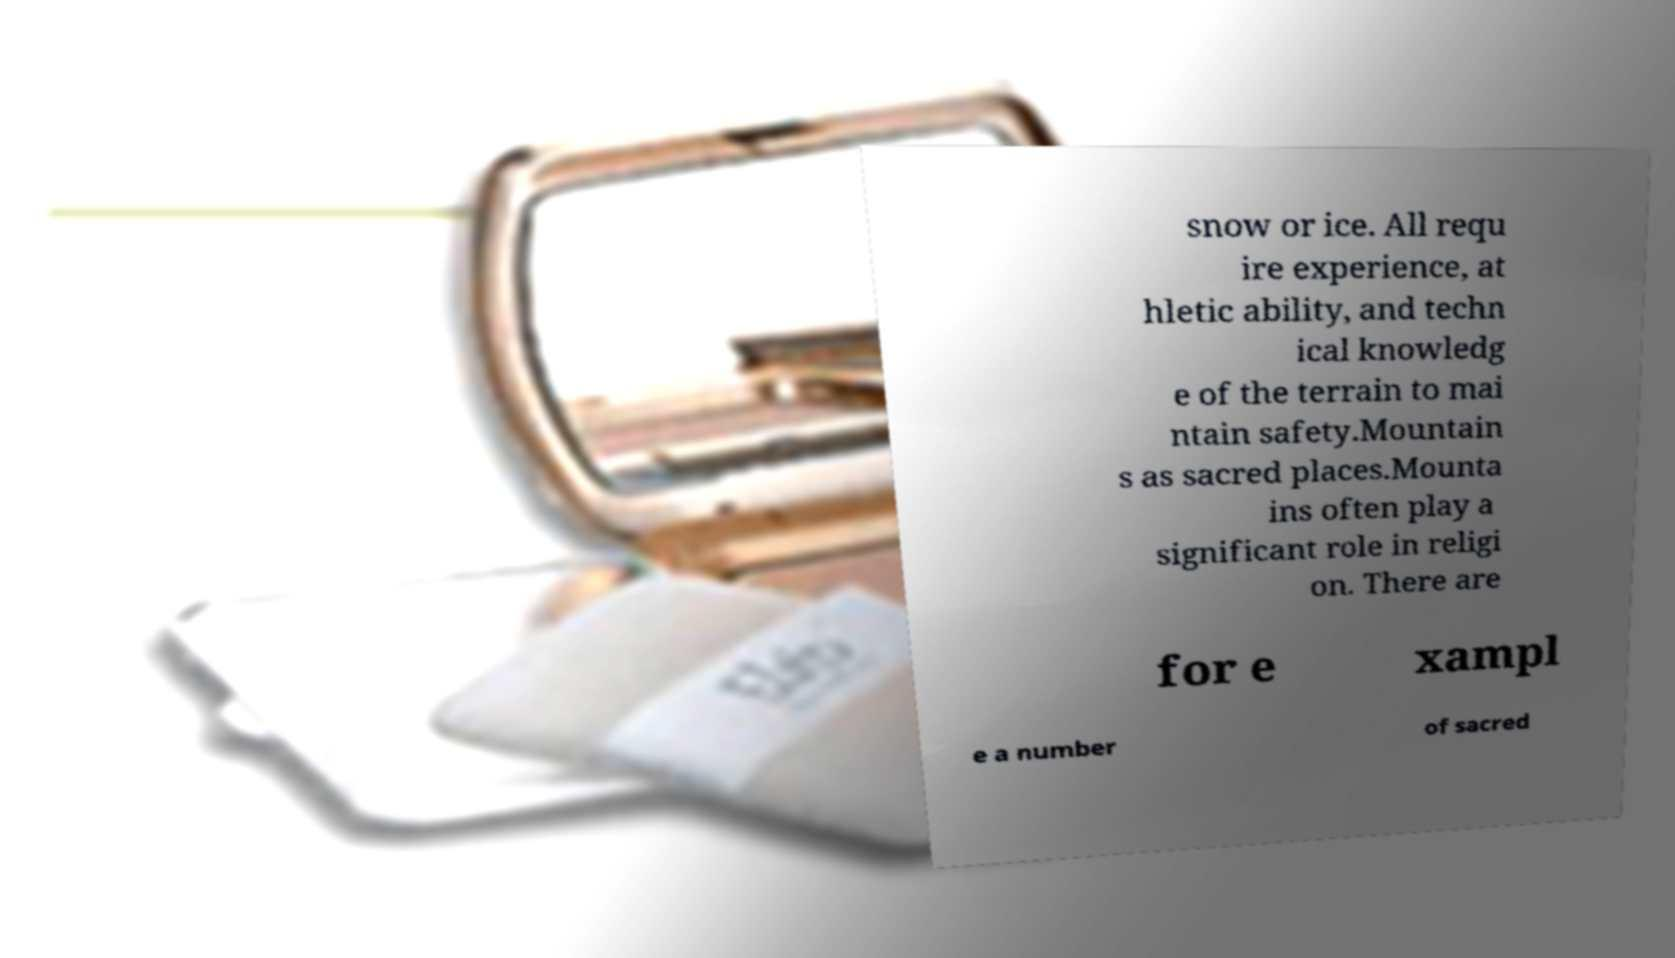Can you read and provide the text displayed in the image?This photo seems to have some interesting text. Can you extract and type it out for me? snow or ice. All requ ire experience, at hletic ability, and techn ical knowledg e of the terrain to mai ntain safety.Mountain s as sacred places.Mounta ins often play a significant role in religi on. There are for e xampl e a number of sacred 